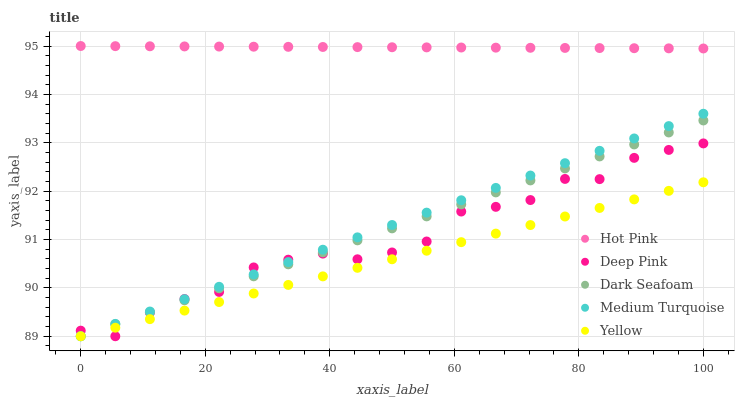Does Yellow have the minimum area under the curve?
Answer yes or no. Yes. Does Hot Pink have the maximum area under the curve?
Answer yes or no. Yes. Does Hot Pink have the minimum area under the curve?
Answer yes or no. No. Does Yellow have the maximum area under the curve?
Answer yes or no. No. Is Medium Turquoise the smoothest?
Answer yes or no. Yes. Is Deep Pink the roughest?
Answer yes or no. Yes. Is Hot Pink the smoothest?
Answer yes or no. No. Is Hot Pink the roughest?
Answer yes or no. No. Does Dark Seafoam have the lowest value?
Answer yes or no. Yes. Does Hot Pink have the lowest value?
Answer yes or no. No. Does Hot Pink have the highest value?
Answer yes or no. Yes. Does Yellow have the highest value?
Answer yes or no. No. Is Yellow less than Hot Pink?
Answer yes or no. Yes. Is Hot Pink greater than Dark Seafoam?
Answer yes or no. Yes. Does Dark Seafoam intersect Yellow?
Answer yes or no. Yes. Is Dark Seafoam less than Yellow?
Answer yes or no. No. Is Dark Seafoam greater than Yellow?
Answer yes or no. No. Does Yellow intersect Hot Pink?
Answer yes or no. No. 